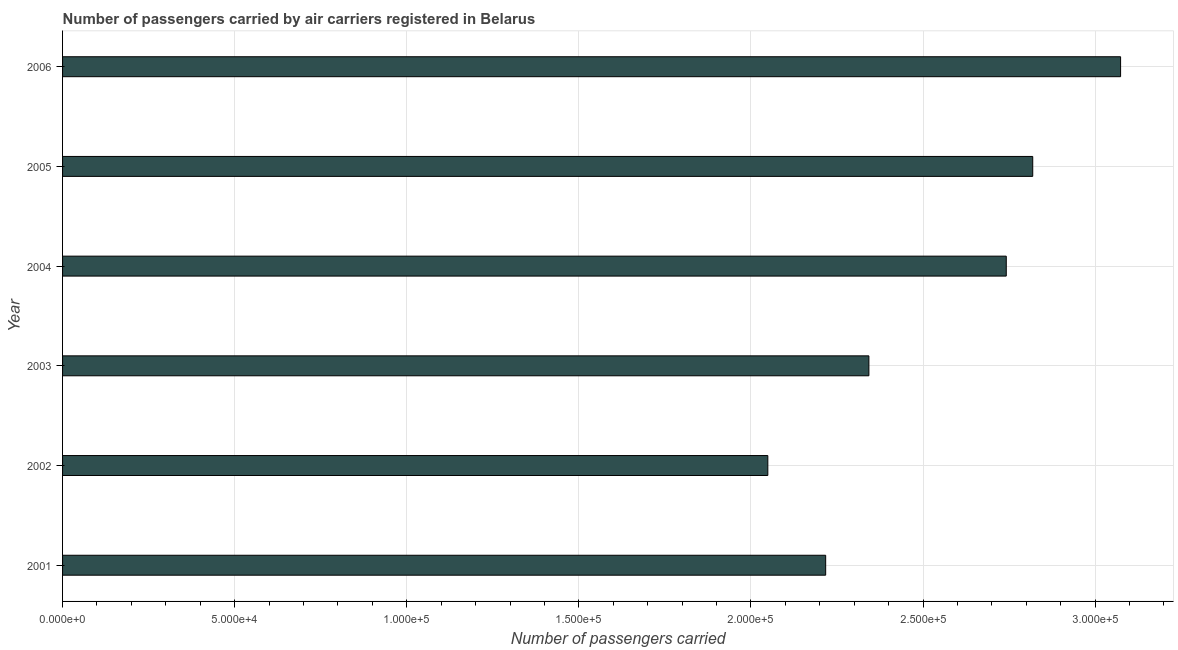What is the title of the graph?
Your response must be concise. Number of passengers carried by air carriers registered in Belarus. What is the label or title of the X-axis?
Your response must be concise. Number of passengers carried. What is the number of passengers carried in 2002?
Make the answer very short. 2.05e+05. Across all years, what is the maximum number of passengers carried?
Your answer should be compact. 3.07e+05. Across all years, what is the minimum number of passengers carried?
Offer a very short reply. 2.05e+05. In which year was the number of passengers carried maximum?
Your response must be concise. 2006. What is the sum of the number of passengers carried?
Ensure brevity in your answer.  1.52e+06. What is the difference between the number of passengers carried in 2002 and 2006?
Make the answer very short. -1.02e+05. What is the average number of passengers carried per year?
Your answer should be very brief. 2.54e+05. What is the median number of passengers carried?
Make the answer very short. 2.54e+05. What is the ratio of the number of passengers carried in 2003 to that in 2004?
Your response must be concise. 0.85. Is the number of passengers carried in 2003 less than that in 2004?
Offer a terse response. Yes. Is the difference between the number of passengers carried in 2005 and 2006 greater than the difference between any two years?
Make the answer very short. No. What is the difference between the highest and the second highest number of passengers carried?
Your answer should be very brief. 2.55e+04. Is the sum of the number of passengers carried in 2005 and 2006 greater than the maximum number of passengers carried across all years?
Provide a succinct answer. Yes. What is the difference between the highest and the lowest number of passengers carried?
Your answer should be very brief. 1.02e+05. In how many years, is the number of passengers carried greater than the average number of passengers carried taken over all years?
Keep it short and to the point. 3. Are all the bars in the graph horizontal?
Provide a succinct answer. Yes. How many years are there in the graph?
Your response must be concise. 6. What is the Number of passengers carried of 2001?
Give a very brief answer. 2.22e+05. What is the Number of passengers carried in 2002?
Give a very brief answer. 2.05e+05. What is the Number of passengers carried in 2003?
Provide a short and direct response. 2.34e+05. What is the Number of passengers carried in 2004?
Your answer should be very brief. 2.74e+05. What is the Number of passengers carried in 2005?
Provide a short and direct response. 2.82e+05. What is the Number of passengers carried in 2006?
Give a very brief answer. 3.07e+05. What is the difference between the Number of passengers carried in 2001 and 2002?
Your answer should be very brief. 1.68e+04. What is the difference between the Number of passengers carried in 2001 and 2003?
Provide a succinct answer. -1.26e+04. What is the difference between the Number of passengers carried in 2001 and 2004?
Ensure brevity in your answer.  -5.25e+04. What is the difference between the Number of passengers carried in 2001 and 2005?
Offer a very short reply. -6.02e+04. What is the difference between the Number of passengers carried in 2001 and 2006?
Ensure brevity in your answer.  -8.57e+04. What is the difference between the Number of passengers carried in 2002 and 2003?
Your response must be concise. -2.94e+04. What is the difference between the Number of passengers carried in 2002 and 2004?
Your answer should be very brief. -6.93e+04. What is the difference between the Number of passengers carried in 2002 and 2005?
Make the answer very short. -7.70e+04. What is the difference between the Number of passengers carried in 2002 and 2006?
Give a very brief answer. -1.02e+05. What is the difference between the Number of passengers carried in 2003 and 2004?
Give a very brief answer. -3.99e+04. What is the difference between the Number of passengers carried in 2003 and 2005?
Your response must be concise. -4.76e+04. What is the difference between the Number of passengers carried in 2003 and 2006?
Your response must be concise. -7.31e+04. What is the difference between the Number of passengers carried in 2004 and 2005?
Your response must be concise. -7692. What is the difference between the Number of passengers carried in 2004 and 2006?
Give a very brief answer. -3.32e+04. What is the difference between the Number of passengers carried in 2005 and 2006?
Your response must be concise. -2.55e+04. What is the ratio of the Number of passengers carried in 2001 to that in 2002?
Your answer should be very brief. 1.08. What is the ratio of the Number of passengers carried in 2001 to that in 2003?
Your response must be concise. 0.95. What is the ratio of the Number of passengers carried in 2001 to that in 2004?
Keep it short and to the point. 0.81. What is the ratio of the Number of passengers carried in 2001 to that in 2005?
Your answer should be compact. 0.79. What is the ratio of the Number of passengers carried in 2001 to that in 2006?
Your answer should be compact. 0.72. What is the ratio of the Number of passengers carried in 2002 to that in 2003?
Give a very brief answer. 0.88. What is the ratio of the Number of passengers carried in 2002 to that in 2004?
Give a very brief answer. 0.75. What is the ratio of the Number of passengers carried in 2002 to that in 2005?
Give a very brief answer. 0.73. What is the ratio of the Number of passengers carried in 2002 to that in 2006?
Keep it short and to the point. 0.67. What is the ratio of the Number of passengers carried in 2003 to that in 2004?
Your answer should be compact. 0.85. What is the ratio of the Number of passengers carried in 2003 to that in 2005?
Provide a succinct answer. 0.83. What is the ratio of the Number of passengers carried in 2003 to that in 2006?
Provide a short and direct response. 0.76. What is the ratio of the Number of passengers carried in 2004 to that in 2005?
Provide a succinct answer. 0.97. What is the ratio of the Number of passengers carried in 2004 to that in 2006?
Offer a terse response. 0.89. What is the ratio of the Number of passengers carried in 2005 to that in 2006?
Your response must be concise. 0.92. 